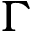<formula> <loc_0><loc_0><loc_500><loc_500>\Gamma</formula> 